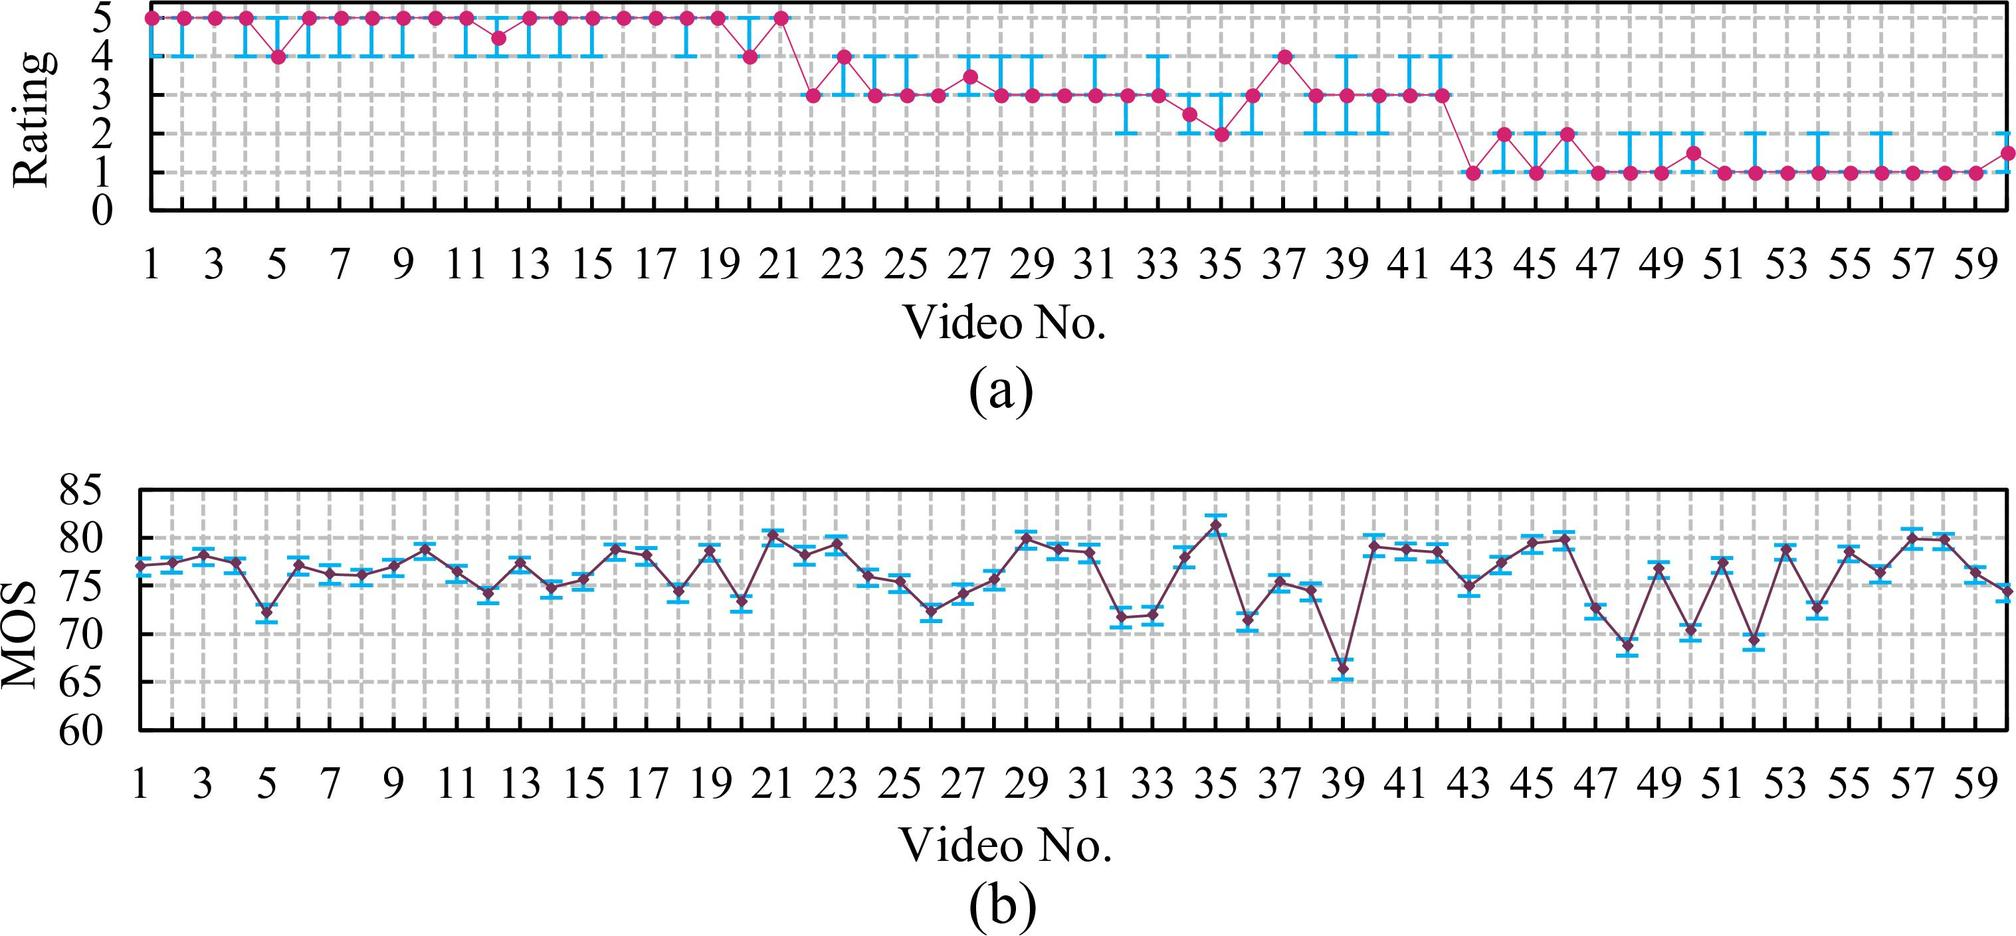Could you explain why the variation in ratings for graph (a) might be important? Certainly! The variation in ratings depicted in graph (a) can offer insights into a number of factors. Fluctuations might suggest diverse audience preferences or inconsistent video content quality. For content creators, understanding these variations is crucial for improving video quality and viewer satisfaction. Moreover, analyzing where and why some videos deviate from the average can highlight what works well and what doesn't, potentially guiding future video production.  Are there any patterns in the fluctuations that might be significant? If we observe the graph closely, we may discern patterns such as certain numbers where the ratings consistently peak or dip. This could indicate recurrent features in the videos that are particularly well-received or not favored by watchers. Identifying and understanding these patterns help to pinpoint what elements might be impacting viewer perception, either positively or negatively. 